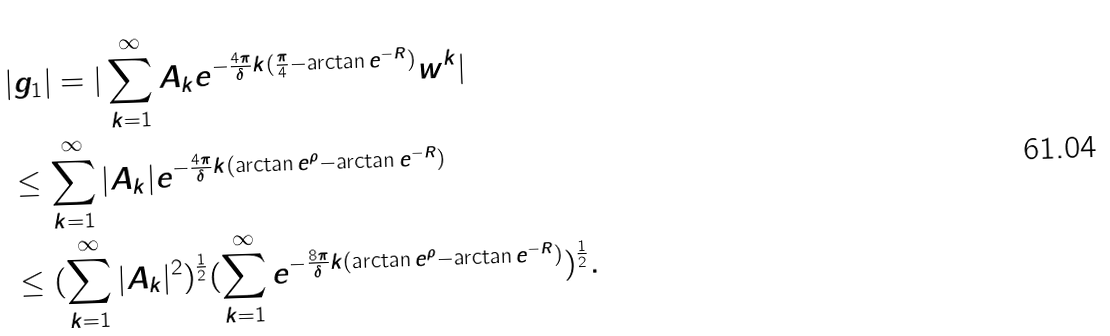Convert formula to latex. <formula><loc_0><loc_0><loc_500><loc_500>& | g _ { 1 } | = | \sum _ { k = 1 } ^ { \infty } A _ { k } e ^ { - \frac { 4 \pi } { \delta } k ( \frac { \pi } { 4 } - \arctan e ^ { - R } ) } w ^ { k } | \\ & \leq \sum _ { k = 1 } ^ { \infty } | A _ { k } | e ^ { - \frac { 4 \pi } { \delta } k ( \arctan e ^ { \rho } - \arctan e ^ { - R } ) } \\ & \leq ( \sum _ { k = 1 } ^ { \infty } | A _ { k } | ^ { 2 } ) ^ { \frac { 1 } { 2 } } ( \sum _ { k = 1 } ^ { \infty } e ^ { - \frac { 8 \pi } { \delta } k ( \arctan e ^ { \rho } - \arctan e ^ { - R } ) } ) ^ { \frac { 1 } { 2 } } .</formula> 